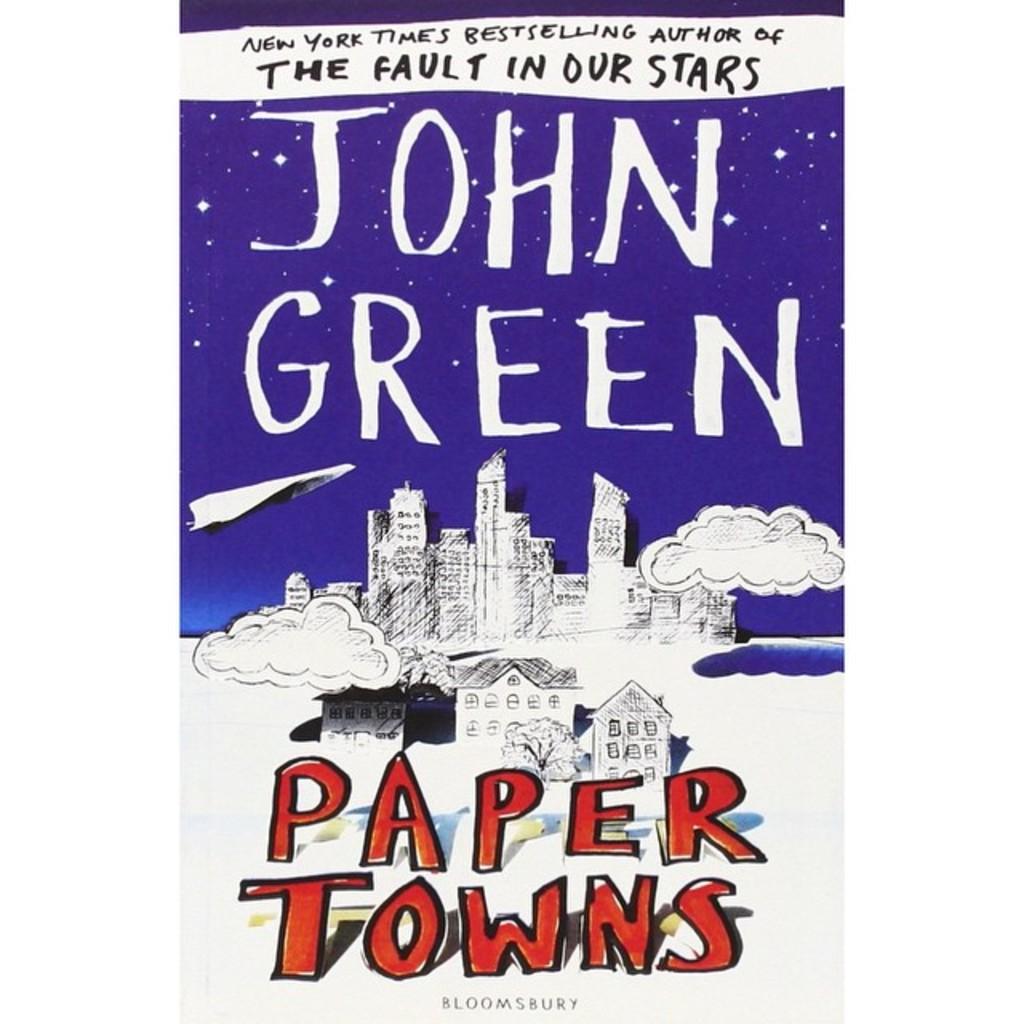What is the title of the book on the new york times bestseller list?
Your response must be concise. Paper towns. What is the authors name of the book?
Keep it short and to the point. John green. 